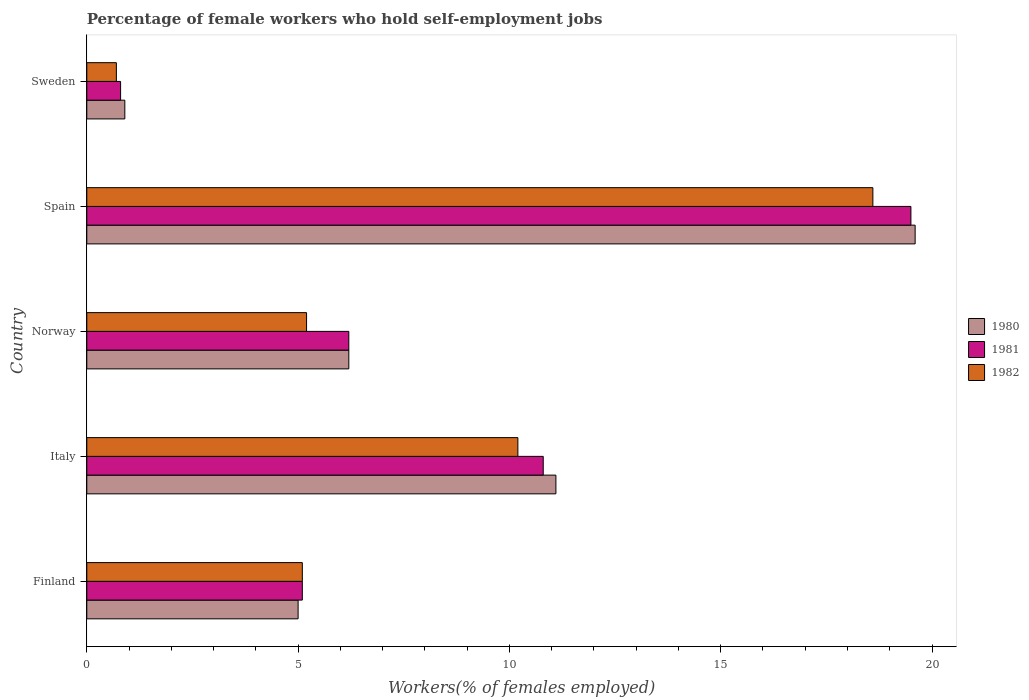How many different coloured bars are there?
Ensure brevity in your answer.  3. How many bars are there on the 2nd tick from the bottom?
Your answer should be compact. 3. What is the percentage of self-employed female workers in 1981 in Norway?
Your response must be concise. 6.2. Across all countries, what is the maximum percentage of self-employed female workers in 1981?
Your response must be concise. 19.5. Across all countries, what is the minimum percentage of self-employed female workers in 1980?
Make the answer very short. 0.9. In which country was the percentage of self-employed female workers in 1981 minimum?
Give a very brief answer. Sweden. What is the total percentage of self-employed female workers in 1982 in the graph?
Keep it short and to the point. 39.8. What is the difference between the percentage of self-employed female workers in 1982 in Italy and that in Sweden?
Keep it short and to the point. 9.5. What is the difference between the percentage of self-employed female workers in 1981 in Norway and the percentage of self-employed female workers in 1982 in Sweden?
Make the answer very short. 5.5. What is the average percentage of self-employed female workers in 1982 per country?
Give a very brief answer. 7.96. What is the difference between the percentage of self-employed female workers in 1980 and percentage of self-employed female workers in 1981 in Sweden?
Make the answer very short. 0.1. In how many countries, is the percentage of self-employed female workers in 1981 greater than 4 %?
Provide a short and direct response. 4. What is the ratio of the percentage of self-employed female workers in 1982 in Finland to that in Norway?
Give a very brief answer. 0.98. Is the difference between the percentage of self-employed female workers in 1980 in Finland and Sweden greater than the difference between the percentage of self-employed female workers in 1981 in Finland and Sweden?
Your answer should be compact. No. What is the difference between the highest and the second highest percentage of self-employed female workers in 1982?
Your answer should be compact. 8.4. What is the difference between the highest and the lowest percentage of self-employed female workers in 1981?
Your response must be concise. 18.7. In how many countries, is the percentage of self-employed female workers in 1982 greater than the average percentage of self-employed female workers in 1982 taken over all countries?
Provide a short and direct response. 2. What does the 3rd bar from the top in Spain represents?
Ensure brevity in your answer.  1980. What does the 3rd bar from the bottom in Finland represents?
Your answer should be compact. 1982. Is it the case that in every country, the sum of the percentage of self-employed female workers in 1981 and percentage of self-employed female workers in 1980 is greater than the percentage of self-employed female workers in 1982?
Keep it short and to the point. Yes. How many bars are there?
Offer a terse response. 15. Are the values on the major ticks of X-axis written in scientific E-notation?
Offer a very short reply. No. Does the graph contain any zero values?
Offer a very short reply. No. Does the graph contain grids?
Your answer should be very brief. No. How many legend labels are there?
Your answer should be compact. 3. How are the legend labels stacked?
Make the answer very short. Vertical. What is the title of the graph?
Give a very brief answer. Percentage of female workers who hold self-employment jobs. What is the label or title of the X-axis?
Offer a very short reply. Workers(% of females employed). What is the Workers(% of females employed) in 1980 in Finland?
Offer a terse response. 5. What is the Workers(% of females employed) of 1981 in Finland?
Provide a short and direct response. 5.1. What is the Workers(% of females employed) of 1982 in Finland?
Offer a very short reply. 5.1. What is the Workers(% of females employed) in 1980 in Italy?
Provide a short and direct response. 11.1. What is the Workers(% of females employed) in 1981 in Italy?
Offer a terse response. 10.8. What is the Workers(% of females employed) in 1982 in Italy?
Ensure brevity in your answer.  10.2. What is the Workers(% of females employed) of 1980 in Norway?
Your response must be concise. 6.2. What is the Workers(% of females employed) of 1981 in Norway?
Give a very brief answer. 6.2. What is the Workers(% of females employed) in 1982 in Norway?
Your answer should be compact. 5.2. What is the Workers(% of females employed) in 1980 in Spain?
Keep it short and to the point. 19.6. What is the Workers(% of females employed) of 1981 in Spain?
Ensure brevity in your answer.  19.5. What is the Workers(% of females employed) in 1982 in Spain?
Make the answer very short. 18.6. What is the Workers(% of females employed) of 1980 in Sweden?
Make the answer very short. 0.9. What is the Workers(% of females employed) in 1981 in Sweden?
Make the answer very short. 0.8. What is the Workers(% of females employed) of 1982 in Sweden?
Make the answer very short. 0.7. Across all countries, what is the maximum Workers(% of females employed) in 1980?
Offer a terse response. 19.6. Across all countries, what is the maximum Workers(% of females employed) of 1981?
Your answer should be very brief. 19.5. Across all countries, what is the maximum Workers(% of females employed) in 1982?
Offer a terse response. 18.6. Across all countries, what is the minimum Workers(% of females employed) of 1980?
Your answer should be very brief. 0.9. Across all countries, what is the minimum Workers(% of females employed) of 1981?
Your answer should be compact. 0.8. Across all countries, what is the minimum Workers(% of females employed) of 1982?
Offer a very short reply. 0.7. What is the total Workers(% of females employed) in 1980 in the graph?
Your answer should be compact. 42.8. What is the total Workers(% of females employed) of 1981 in the graph?
Provide a short and direct response. 42.4. What is the total Workers(% of females employed) of 1982 in the graph?
Your response must be concise. 39.8. What is the difference between the Workers(% of females employed) in 1982 in Finland and that in Italy?
Ensure brevity in your answer.  -5.1. What is the difference between the Workers(% of females employed) of 1980 in Finland and that in Norway?
Provide a succinct answer. -1.2. What is the difference between the Workers(% of females employed) of 1982 in Finland and that in Norway?
Offer a very short reply. -0.1. What is the difference between the Workers(% of females employed) in 1980 in Finland and that in Spain?
Give a very brief answer. -14.6. What is the difference between the Workers(% of females employed) of 1981 in Finland and that in Spain?
Give a very brief answer. -14.4. What is the difference between the Workers(% of females employed) in 1982 in Finland and that in Spain?
Keep it short and to the point. -13.5. What is the difference between the Workers(% of females employed) of 1980 in Finland and that in Sweden?
Your answer should be compact. 4.1. What is the difference between the Workers(% of females employed) in 1981 in Finland and that in Sweden?
Provide a succinct answer. 4.3. What is the difference between the Workers(% of females employed) of 1982 in Finland and that in Sweden?
Make the answer very short. 4.4. What is the difference between the Workers(% of females employed) in 1982 in Italy and that in Norway?
Offer a terse response. 5. What is the difference between the Workers(% of females employed) in 1982 in Italy and that in Spain?
Ensure brevity in your answer.  -8.4. What is the difference between the Workers(% of females employed) in 1980 in Italy and that in Sweden?
Your answer should be very brief. 10.2. What is the difference between the Workers(% of females employed) in 1981 in Italy and that in Sweden?
Ensure brevity in your answer.  10. What is the difference between the Workers(% of females employed) in 1982 in Italy and that in Sweden?
Provide a short and direct response. 9.5. What is the difference between the Workers(% of females employed) of 1980 in Norway and that in Spain?
Your answer should be compact. -13.4. What is the difference between the Workers(% of females employed) of 1981 in Norway and that in Spain?
Provide a short and direct response. -13.3. What is the difference between the Workers(% of females employed) in 1982 in Norway and that in Spain?
Provide a succinct answer. -13.4. What is the difference between the Workers(% of females employed) of 1980 in Norway and that in Sweden?
Ensure brevity in your answer.  5.3. What is the difference between the Workers(% of females employed) of 1981 in Norway and that in Sweden?
Your answer should be very brief. 5.4. What is the difference between the Workers(% of females employed) of 1982 in Spain and that in Sweden?
Provide a succinct answer. 17.9. What is the difference between the Workers(% of females employed) in 1980 in Finland and the Workers(% of females employed) in 1981 in Italy?
Your answer should be compact. -5.8. What is the difference between the Workers(% of females employed) of 1980 in Finland and the Workers(% of females employed) of 1981 in Spain?
Make the answer very short. -14.5. What is the difference between the Workers(% of females employed) of 1980 in Finland and the Workers(% of females employed) of 1981 in Sweden?
Your response must be concise. 4.2. What is the difference between the Workers(% of females employed) of 1981 in Finland and the Workers(% of females employed) of 1982 in Sweden?
Your answer should be very brief. 4.4. What is the difference between the Workers(% of females employed) in 1980 in Italy and the Workers(% of females employed) in 1981 in Spain?
Make the answer very short. -8.4. What is the difference between the Workers(% of females employed) in 1980 in Italy and the Workers(% of females employed) in 1982 in Sweden?
Provide a short and direct response. 10.4. What is the difference between the Workers(% of females employed) of 1981 in Italy and the Workers(% of females employed) of 1982 in Sweden?
Your answer should be compact. 10.1. What is the difference between the Workers(% of females employed) in 1980 in Norway and the Workers(% of females employed) in 1981 in Spain?
Offer a very short reply. -13.3. What is the difference between the Workers(% of females employed) in 1981 in Norway and the Workers(% of females employed) in 1982 in Spain?
Make the answer very short. -12.4. What is the difference between the Workers(% of females employed) in 1980 in Norway and the Workers(% of females employed) in 1981 in Sweden?
Provide a succinct answer. 5.4. What is the difference between the Workers(% of females employed) in 1980 in Norway and the Workers(% of females employed) in 1982 in Sweden?
Offer a very short reply. 5.5. What is the difference between the Workers(% of females employed) in 1981 in Norway and the Workers(% of females employed) in 1982 in Sweden?
Your answer should be compact. 5.5. What is the difference between the Workers(% of females employed) of 1980 in Spain and the Workers(% of females employed) of 1981 in Sweden?
Keep it short and to the point. 18.8. What is the difference between the Workers(% of females employed) in 1980 in Spain and the Workers(% of females employed) in 1982 in Sweden?
Your answer should be very brief. 18.9. What is the average Workers(% of females employed) of 1980 per country?
Your answer should be compact. 8.56. What is the average Workers(% of females employed) in 1981 per country?
Keep it short and to the point. 8.48. What is the average Workers(% of females employed) of 1982 per country?
Offer a terse response. 7.96. What is the difference between the Workers(% of females employed) of 1980 and Workers(% of females employed) of 1982 in Italy?
Your answer should be compact. 0.9. What is the difference between the Workers(% of females employed) of 1981 and Workers(% of females employed) of 1982 in Norway?
Your response must be concise. 1. What is the difference between the Workers(% of females employed) of 1980 and Workers(% of females employed) of 1981 in Spain?
Your answer should be compact. 0.1. What is the difference between the Workers(% of females employed) of 1980 and Workers(% of females employed) of 1981 in Sweden?
Keep it short and to the point. 0.1. What is the difference between the Workers(% of females employed) of 1980 and Workers(% of females employed) of 1982 in Sweden?
Give a very brief answer. 0.2. What is the ratio of the Workers(% of females employed) in 1980 in Finland to that in Italy?
Ensure brevity in your answer.  0.45. What is the ratio of the Workers(% of females employed) in 1981 in Finland to that in Italy?
Your answer should be very brief. 0.47. What is the ratio of the Workers(% of females employed) of 1980 in Finland to that in Norway?
Offer a terse response. 0.81. What is the ratio of the Workers(% of females employed) in 1981 in Finland to that in Norway?
Make the answer very short. 0.82. What is the ratio of the Workers(% of females employed) in 1982 in Finland to that in Norway?
Give a very brief answer. 0.98. What is the ratio of the Workers(% of females employed) in 1980 in Finland to that in Spain?
Your answer should be compact. 0.26. What is the ratio of the Workers(% of females employed) in 1981 in Finland to that in Spain?
Ensure brevity in your answer.  0.26. What is the ratio of the Workers(% of females employed) of 1982 in Finland to that in Spain?
Provide a short and direct response. 0.27. What is the ratio of the Workers(% of females employed) of 1980 in Finland to that in Sweden?
Make the answer very short. 5.56. What is the ratio of the Workers(% of females employed) of 1981 in Finland to that in Sweden?
Offer a very short reply. 6.38. What is the ratio of the Workers(% of females employed) of 1982 in Finland to that in Sweden?
Offer a very short reply. 7.29. What is the ratio of the Workers(% of females employed) in 1980 in Italy to that in Norway?
Your response must be concise. 1.79. What is the ratio of the Workers(% of females employed) of 1981 in Italy to that in Norway?
Keep it short and to the point. 1.74. What is the ratio of the Workers(% of females employed) of 1982 in Italy to that in Norway?
Your answer should be very brief. 1.96. What is the ratio of the Workers(% of females employed) of 1980 in Italy to that in Spain?
Make the answer very short. 0.57. What is the ratio of the Workers(% of females employed) of 1981 in Italy to that in Spain?
Keep it short and to the point. 0.55. What is the ratio of the Workers(% of females employed) in 1982 in Italy to that in Spain?
Your answer should be compact. 0.55. What is the ratio of the Workers(% of females employed) in 1980 in Italy to that in Sweden?
Provide a short and direct response. 12.33. What is the ratio of the Workers(% of females employed) in 1981 in Italy to that in Sweden?
Offer a very short reply. 13.5. What is the ratio of the Workers(% of females employed) of 1982 in Italy to that in Sweden?
Your response must be concise. 14.57. What is the ratio of the Workers(% of females employed) of 1980 in Norway to that in Spain?
Provide a short and direct response. 0.32. What is the ratio of the Workers(% of females employed) in 1981 in Norway to that in Spain?
Offer a very short reply. 0.32. What is the ratio of the Workers(% of females employed) in 1982 in Norway to that in Spain?
Provide a succinct answer. 0.28. What is the ratio of the Workers(% of females employed) of 1980 in Norway to that in Sweden?
Ensure brevity in your answer.  6.89. What is the ratio of the Workers(% of females employed) of 1981 in Norway to that in Sweden?
Your answer should be compact. 7.75. What is the ratio of the Workers(% of females employed) of 1982 in Norway to that in Sweden?
Offer a very short reply. 7.43. What is the ratio of the Workers(% of females employed) in 1980 in Spain to that in Sweden?
Provide a succinct answer. 21.78. What is the ratio of the Workers(% of females employed) in 1981 in Spain to that in Sweden?
Make the answer very short. 24.38. What is the ratio of the Workers(% of females employed) in 1982 in Spain to that in Sweden?
Offer a very short reply. 26.57. What is the difference between the highest and the second highest Workers(% of females employed) of 1982?
Ensure brevity in your answer.  8.4. What is the difference between the highest and the lowest Workers(% of females employed) of 1981?
Offer a terse response. 18.7. 